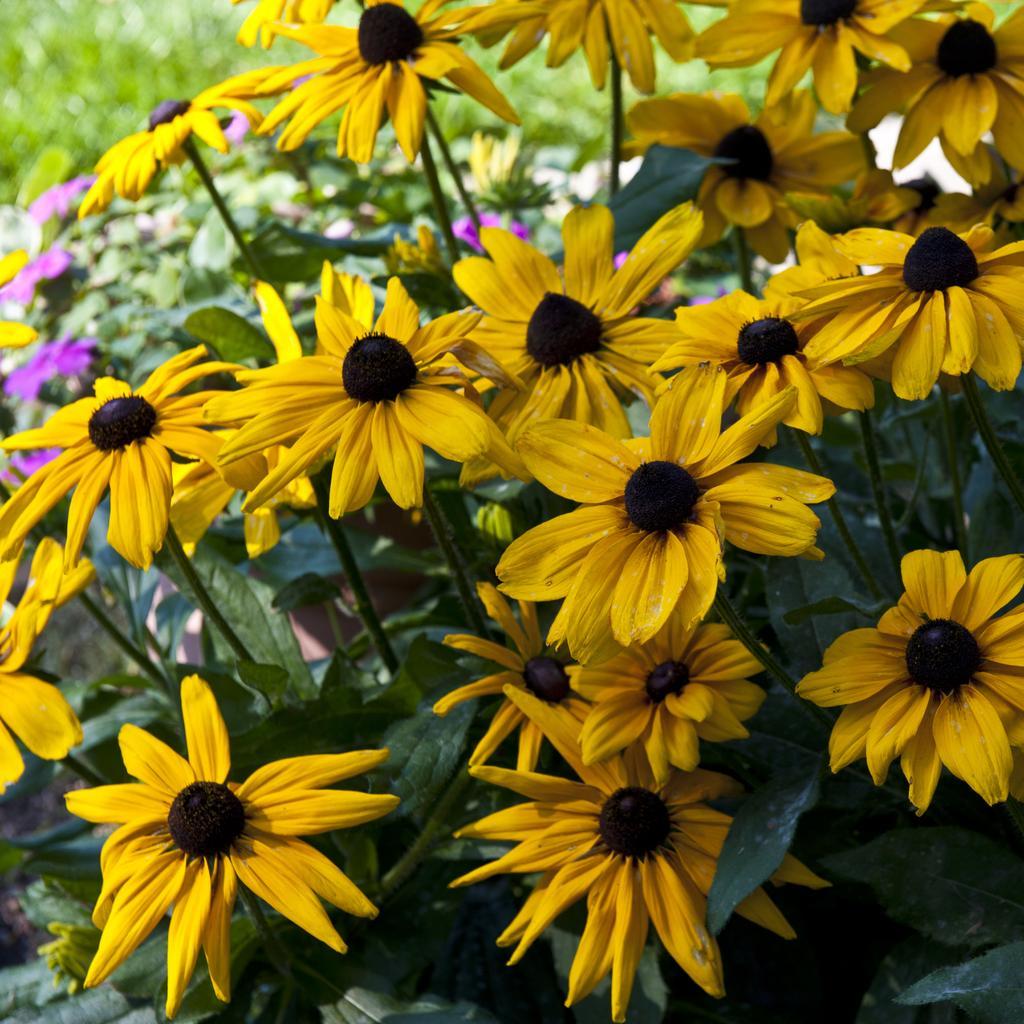Could you give a brief overview of what you see in this image? In this image we can see flowers and plants. 